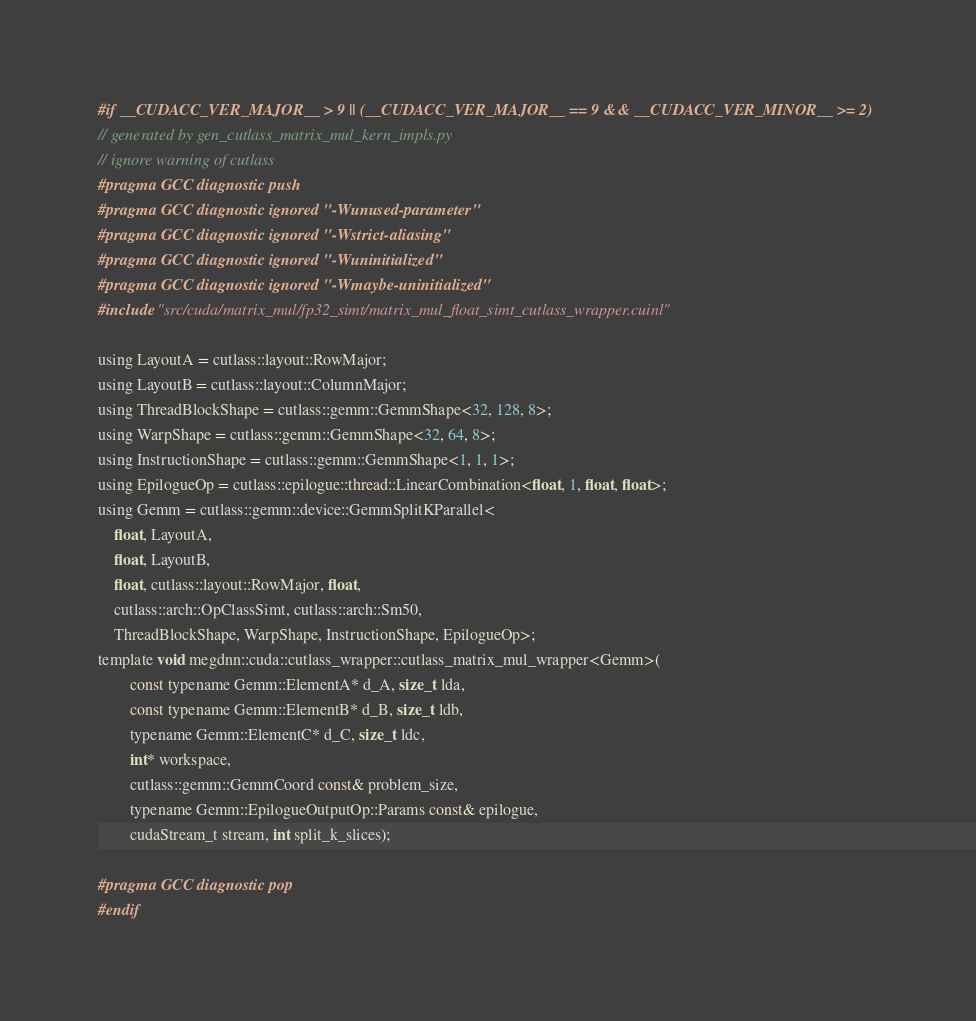<code> <loc_0><loc_0><loc_500><loc_500><_Cuda_>#if __CUDACC_VER_MAJOR__ > 9 || (__CUDACC_VER_MAJOR__ == 9 && __CUDACC_VER_MINOR__ >= 2)
// generated by gen_cutlass_matrix_mul_kern_impls.py
// ignore warning of cutlass
#pragma GCC diagnostic push
#pragma GCC diagnostic ignored "-Wunused-parameter"
#pragma GCC diagnostic ignored "-Wstrict-aliasing"
#pragma GCC diagnostic ignored "-Wuninitialized"
#pragma GCC diagnostic ignored "-Wmaybe-uninitialized"
#include "src/cuda/matrix_mul/fp32_simt/matrix_mul_float_simt_cutlass_wrapper.cuinl"

using LayoutA = cutlass::layout::RowMajor;
using LayoutB = cutlass::layout::ColumnMajor;
using ThreadBlockShape = cutlass::gemm::GemmShape<32, 128, 8>;
using WarpShape = cutlass::gemm::GemmShape<32, 64, 8>;
using InstructionShape = cutlass::gemm::GemmShape<1, 1, 1>;
using EpilogueOp = cutlass::epilogue::thread::LinearCombination<float, 1, float, float>;
using Gemm = cutlass::gemm::device::GemmSplitKParallel<
    float, LayoutA, 
    float, LayoutB, 
    float, cutlass::layout::RowMajor, float, 
    cutlass::arch::OpClassSimt, cutlass::arch::Sm50, 
    ThreadBlockShape, WarpShape, InstructionShape, EpilogueOp>;
template void megdnn::cuda::cutlass_wrapper::cutlass_matrix_mul_wrapper<Gemm>(
        const typename Gemm::ElementA* d_A, size_t lda, 
        const typename Gemm::ElementB* d_B, size_t ldb,  
        typename Gemm::ElementC* d_C, size_t ldc,  
        int* workspace, 
        cutlass::gemm::GemmCoord const& problem_size,   
        typename Gemm::EpilogueOutputOp::Params const& epilogue, 
        cudaStream_t stream, int split_k_slices);

#pragma GCC diagnostic pop
#endif
</code> 